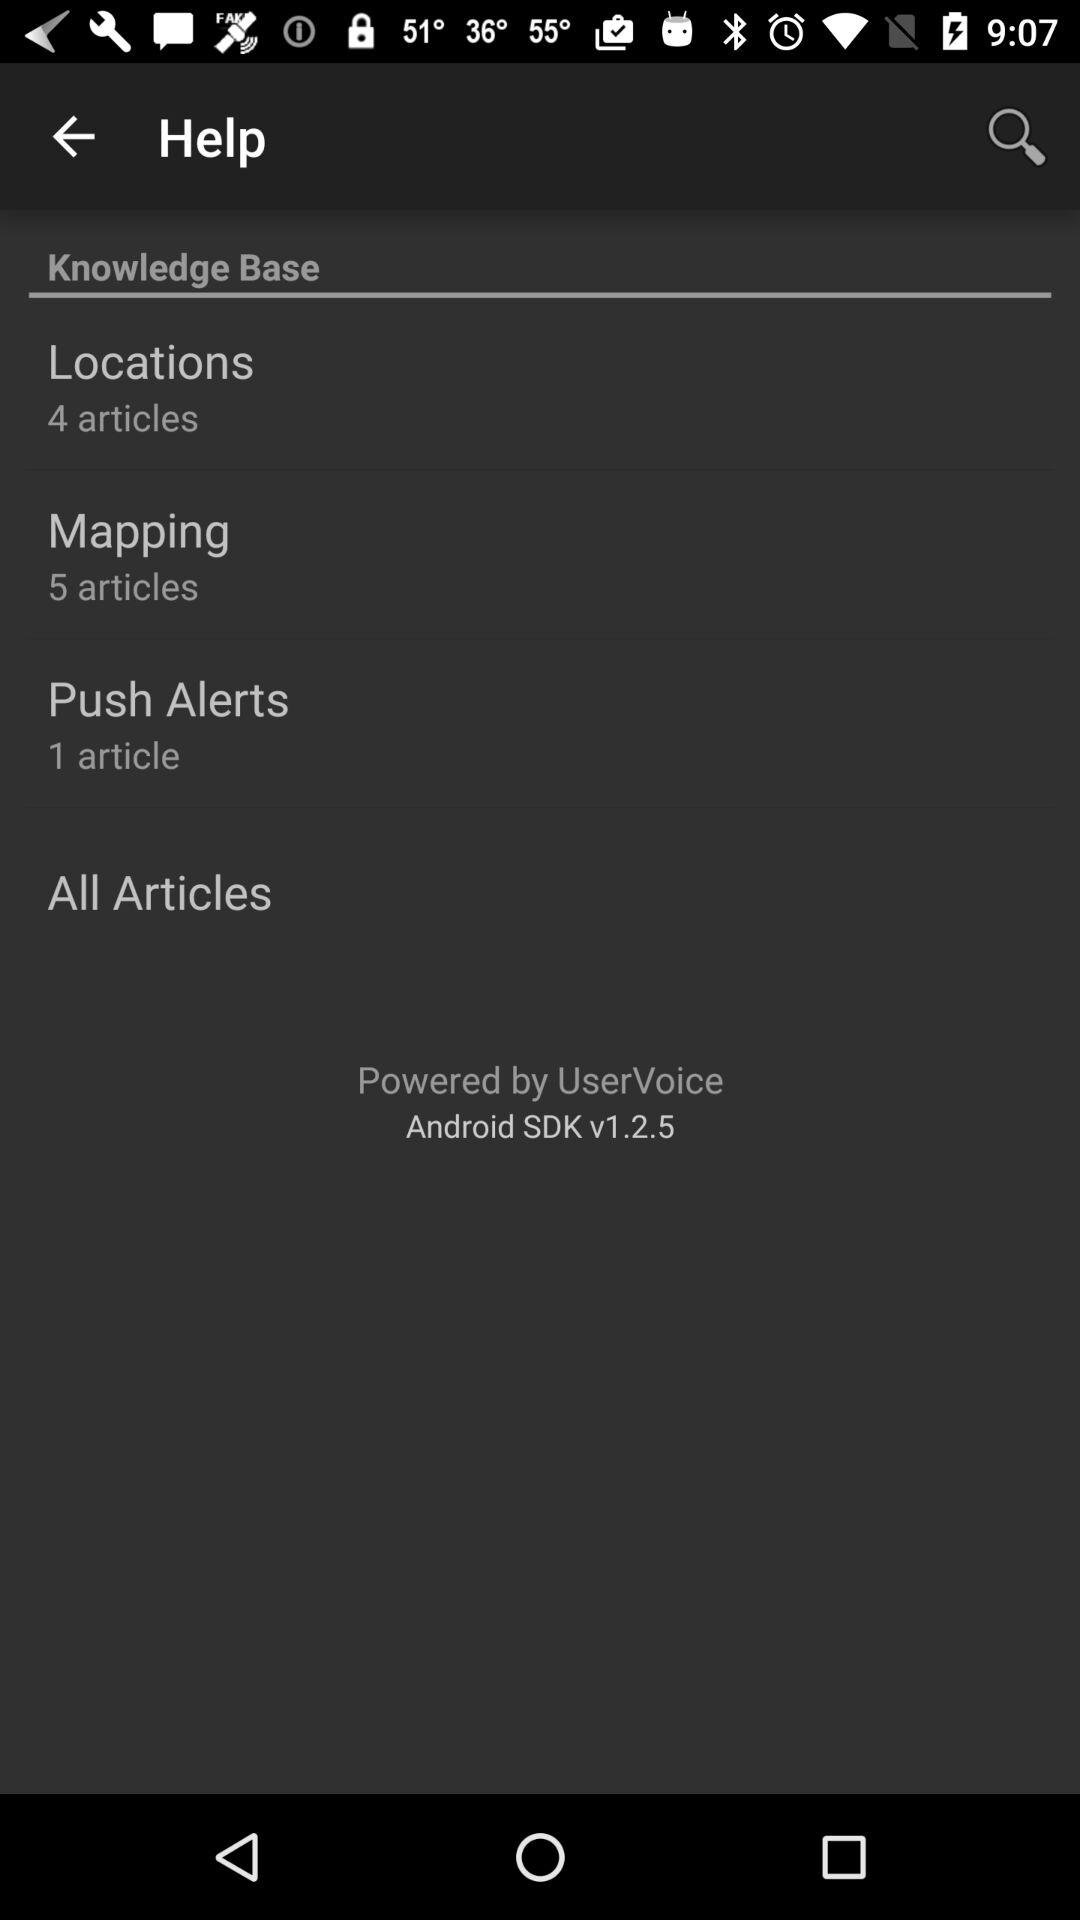How many articles are there in total?
Answer the question using a single word or phrase. 10 